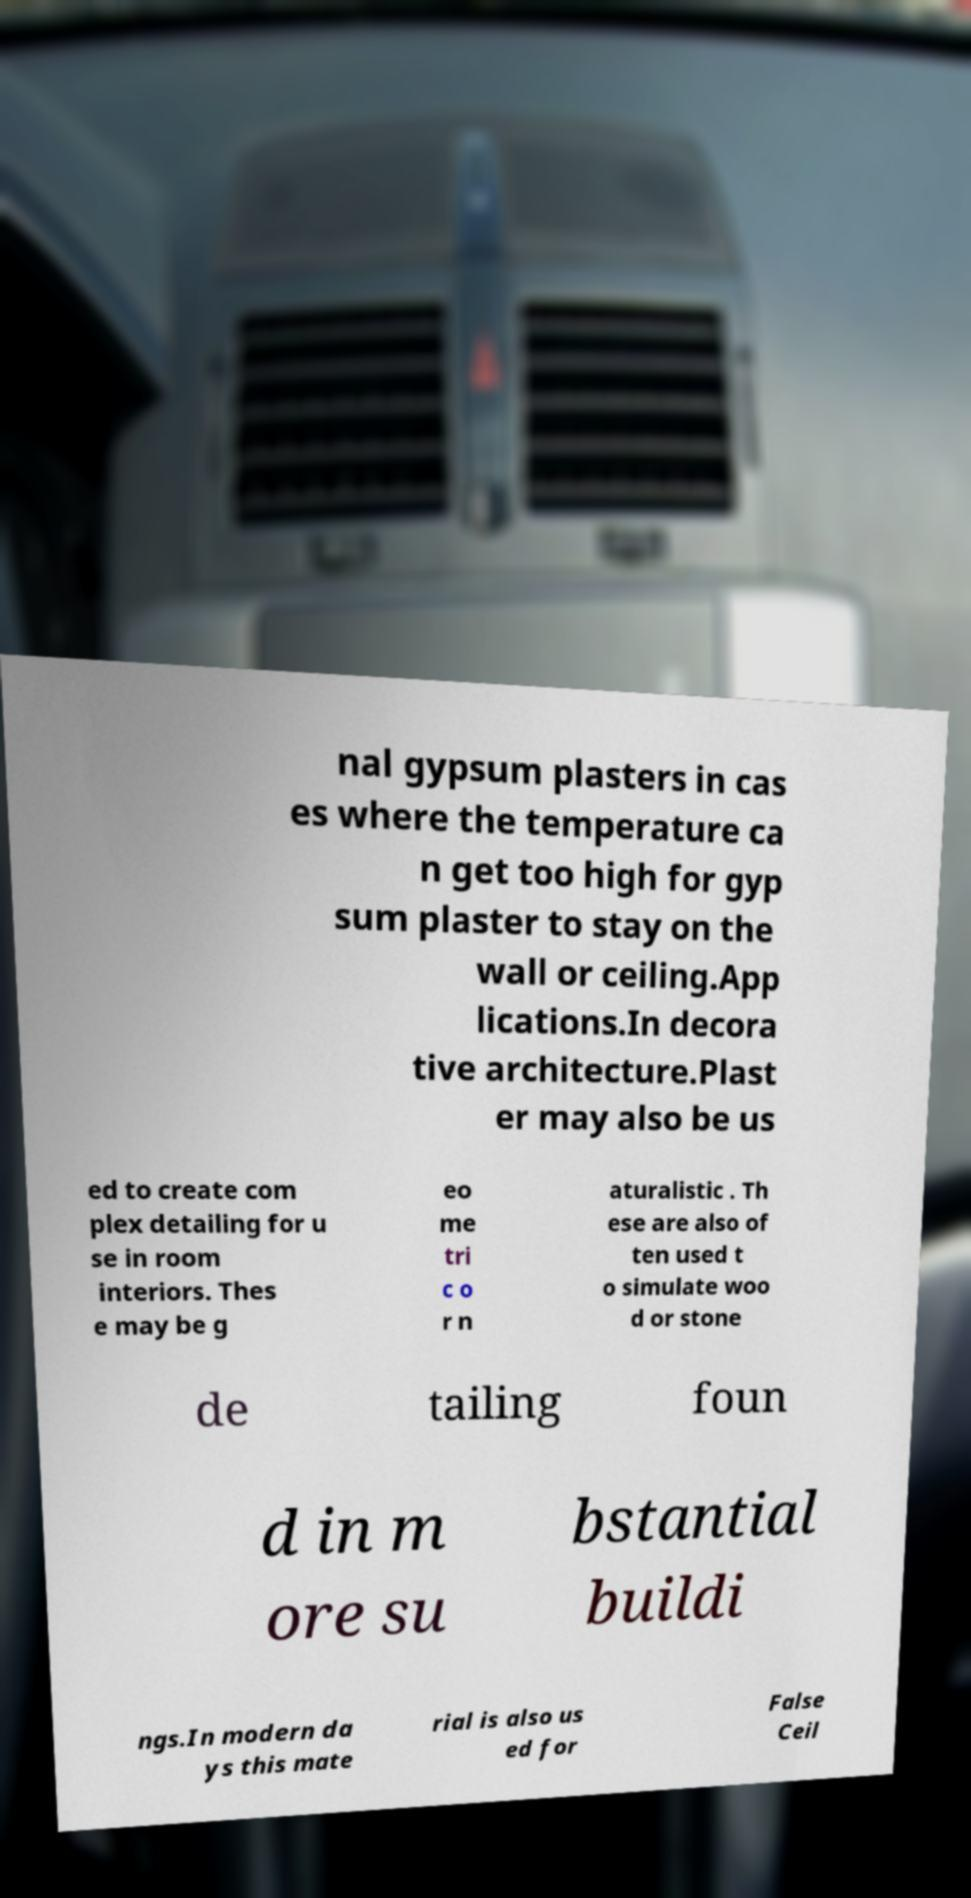Can you read and provide the text displayed in the image?This photo seems to have some interesting text. Can you extract and type it out for me? nal gypsum plasters in cas es where the temperature ca n get too high for gyp sum plaster to stay on the wall or ceiling.App lications.In decora tive architecture.Plast er may also be us ed to create com plex detailing for u se in room interiors. Thes e may be g eo me tri c o r n aturalistic . Th ese are also of ten used t o simulate woo d or stone de tailing foun d in m ore su bstantial buildi ngs.In modern da ys this mate rial is also us ed for False Ceil 